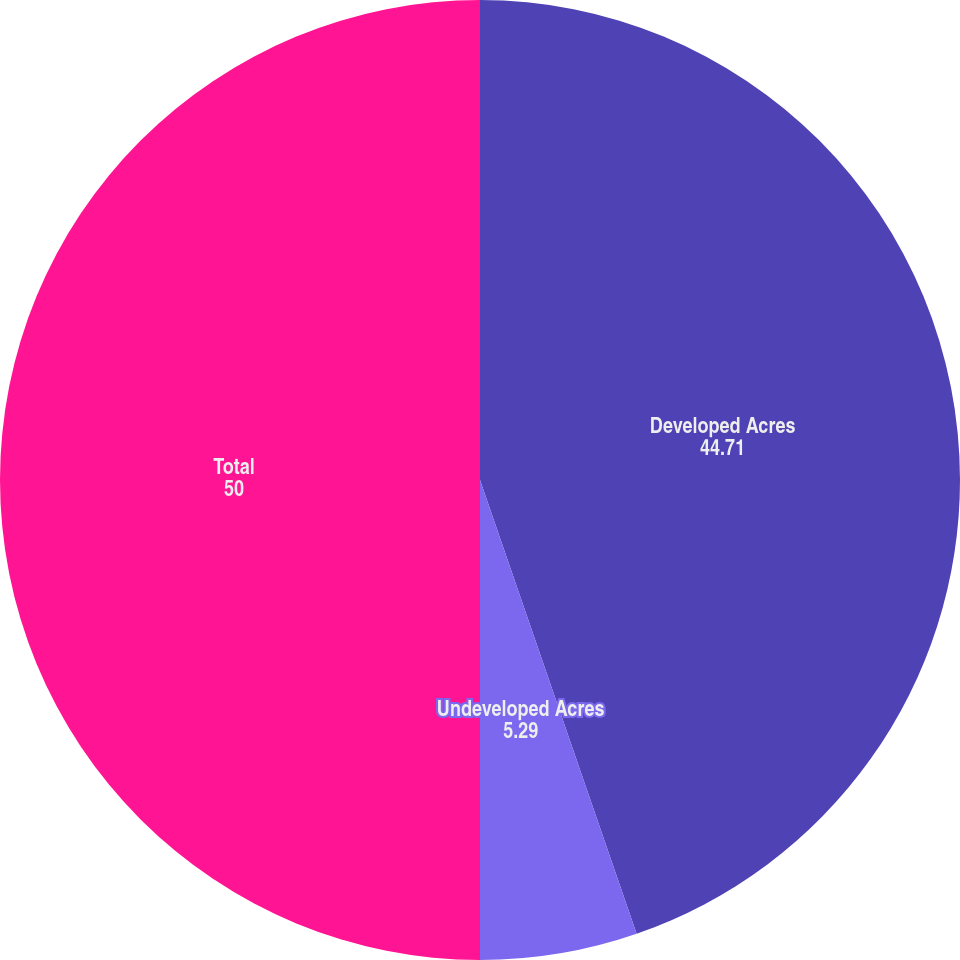<chart> <loc_0><loc_0><loc_500><loc_500><pie_chart><fcel>Developed Acres<fcel>Undeveloped Acres<fcel>Total<nl><fcel>44.71%<fcel>5.29%<fcel>50.0%<nl></chart> 